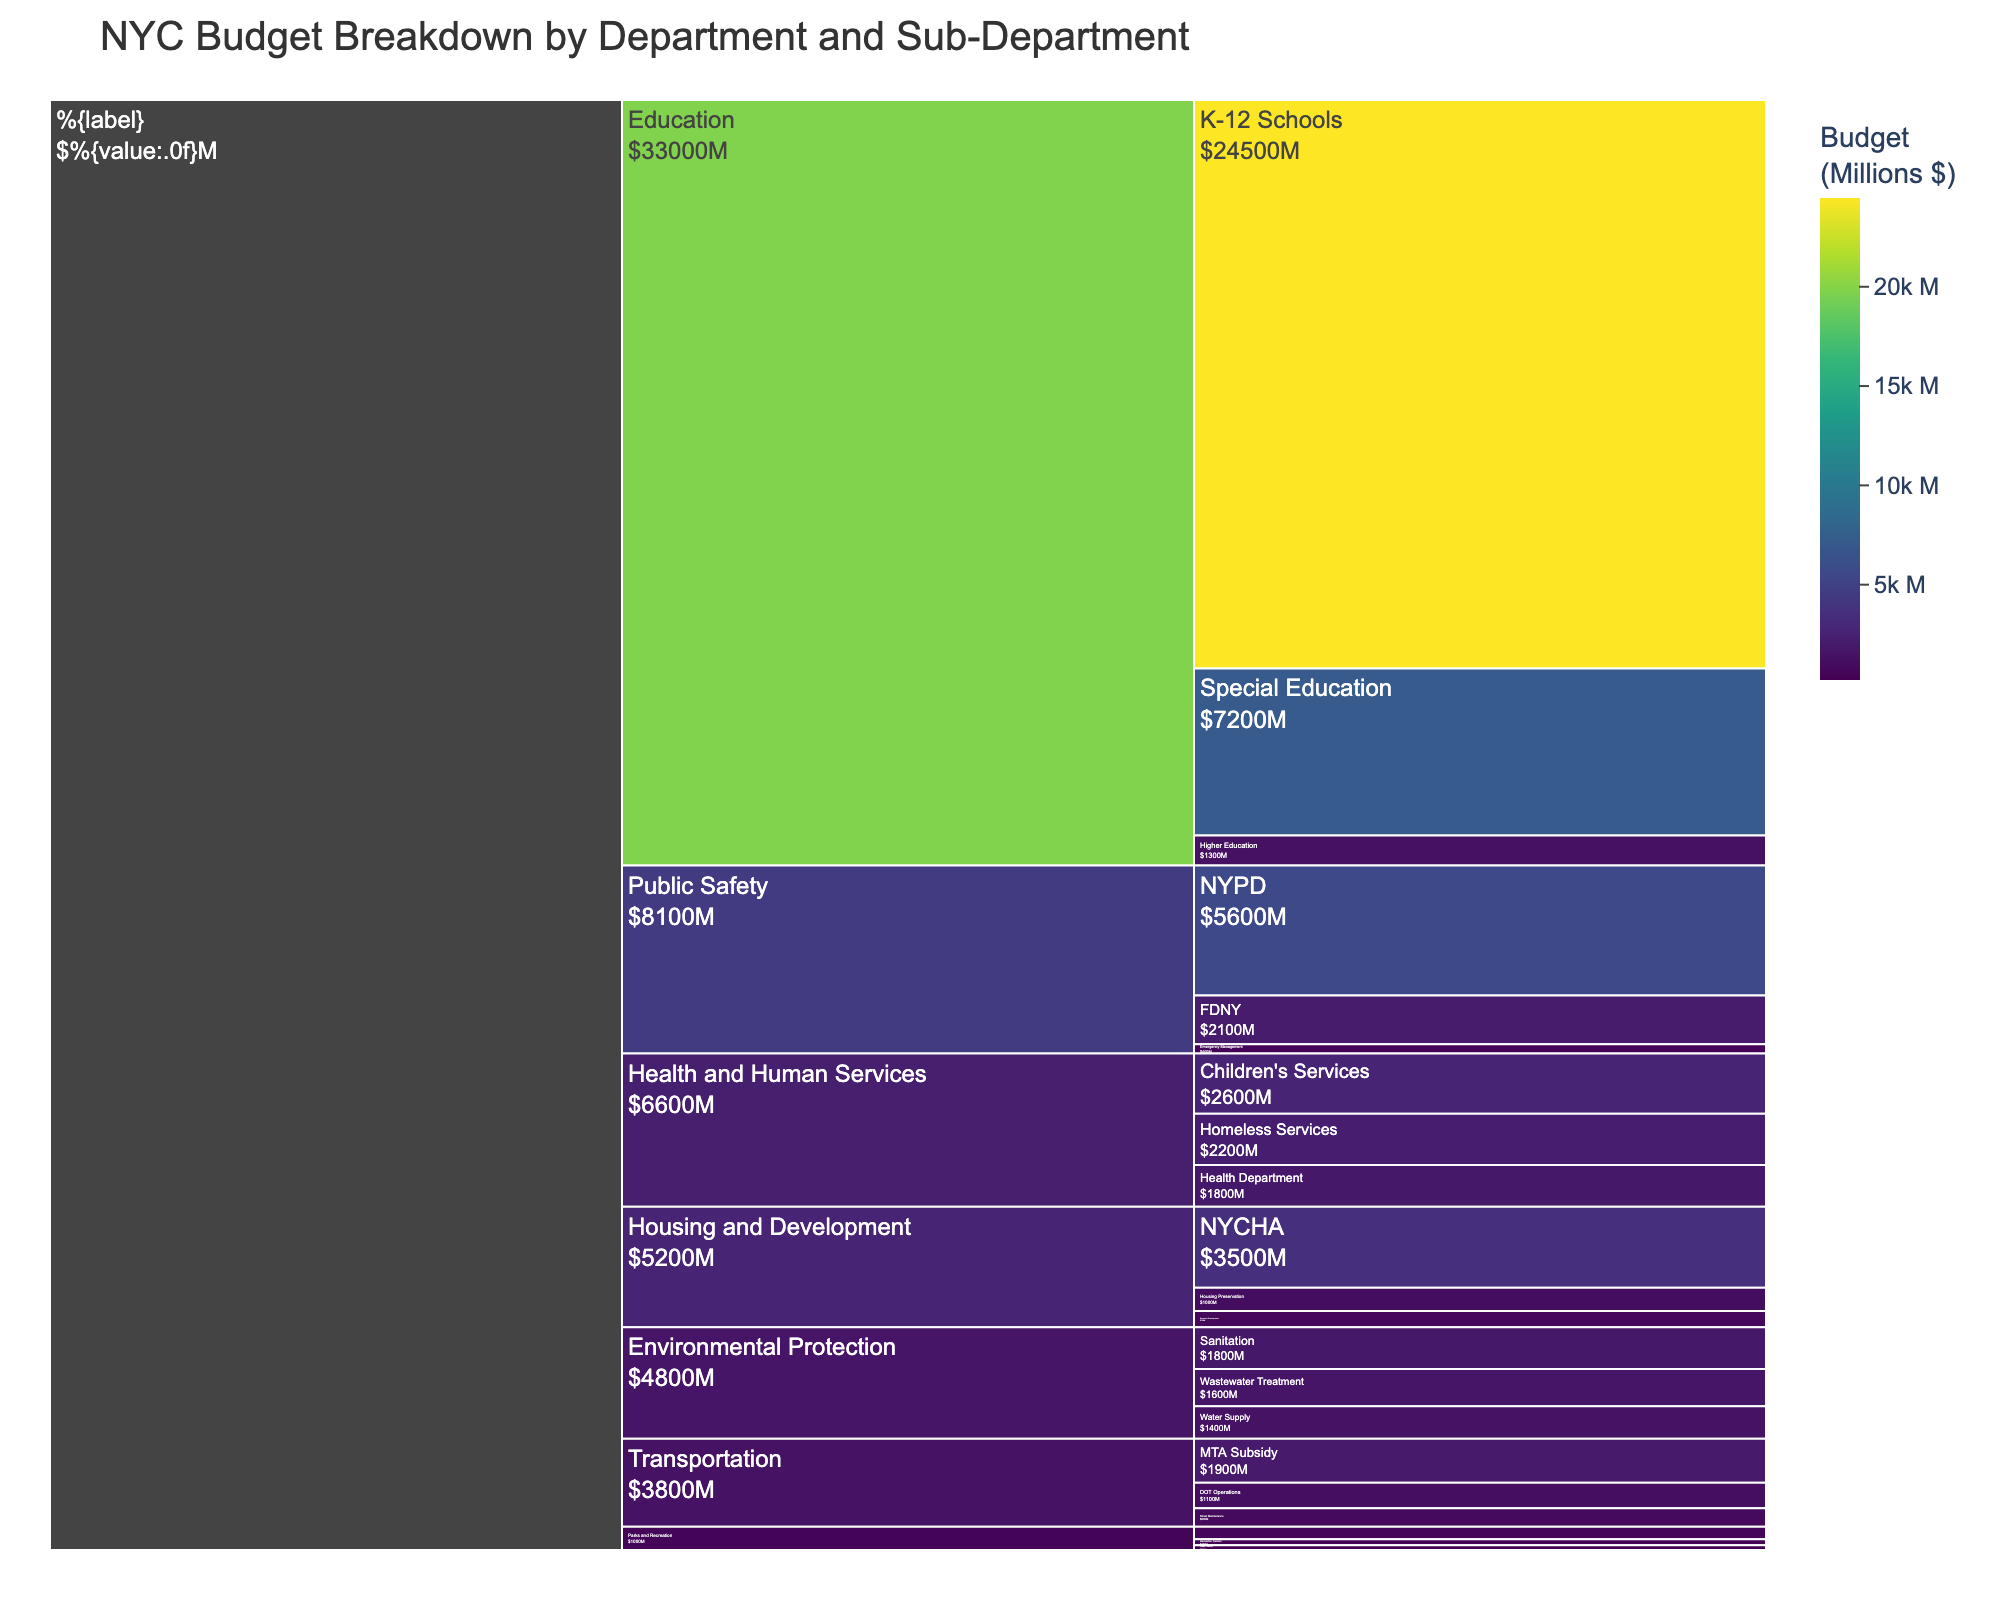What's the total budget allocated to the Education Department? Sum the budgets of the sub-departments: K-12 Schools ($24,500M), Special Education ($7,200M), and Higher Education ($1,300M). So, $24,500M + $7,200M + $1,300M = $33,000M.
Answer: $33,000M Which sub-department under Public Safety has the highest budget? Compare the budgets of NYPD ($5,600M), FDNY ($2,100M), and Emergency Management ($400M). NYPD has the highest budget.
Answer: NYPD How does the budget of the Health Department compare to that of the Children's Services? The Health Department has a budget of $1,800M, while Children's Services has a budget of $2,600M. Since $2,600M > $1,800M, the Children's Services budget is greater.
Answer: The budget of Children's Services is greater What's the combined budget for the Housing and Development sub-departments? Sum the budgets of NYCHA ($3,500M), Housing Preservation ($1,000M), and Economic Development ($700M). So, $3,500M + $1,000M + $700M = $5,200M.
Answer: $5,200M Which department has the least budget, and what is its main sub-department? Determine the smallest budget among departments: Education ($33,000M), Public Safety ($8,100M), Health and Human Services ($6,600M), Transportation ($3,800M), Housing and Development ($5,200M), Environmental Protection ($4,000M), Parks and Recreation ($1,000M). Parks and Recreation has the least budget at $1,000M. The main sub-department in terms of budget is Park Maintenance ($540M).
Answer: Parks and Recreation, Park Maintenance What's the total budget for all the sub-departments under Environmental Protection? Sum the budgets of Water Supply ($1,400M), Wastewater Treatment ($1,600M), and Sanitation ($1,800M). So, $1,400M + $1,600M + $1,800M = $4,800M. Note that this total exceeds the department budget, indicating overlapping or additional sources. Consider department total if conflicting data.
Answer: $4,800M (if not corrected) Which transportation sub-department has the highest budget, and by how much does it exceed the next highest sub-department? Compare sub-department budgets: MTA Subsidy ($1,900M), DOT Operations ($1,100M), and Street Maintenance ($800M). MTA Subsidy has the highest budget. Difference between MTA Subsidy and DOT Operations: $1,900M - $1,100M = $800M.
Answer: MTA Subsidy, by $800M What fraction of the total Transportation budget is allocated to MTA Subsidy? Total Transportation budget is $3,800M. The MTA Subsidy budget is $1,900M. Fraction is $1,900M / $3,800M = 1/2 or 50%.
Answer: 1/2 or 50% Which department has the second highest overall budget? Compare overall budgets: Education ($33,000M), Public Safety ($8,100M), Health and Human Services ($6,600M), Transportation ($3,800M), Housing and Development ($5,200M), Environmental Protection ($4,000M), Parks and Recreation ($1,000M). Public Safety has the second highest budget.
Answer: Public Safety 